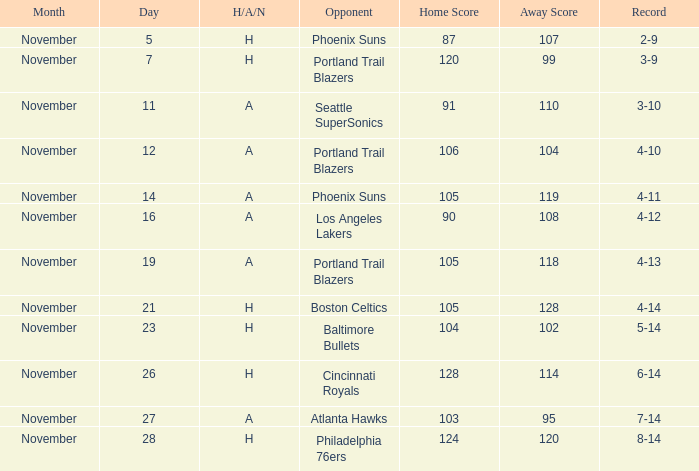What is the Opponent of the game with a H/A/N of H and Score of 120-99? Portland Trail Blazers. 